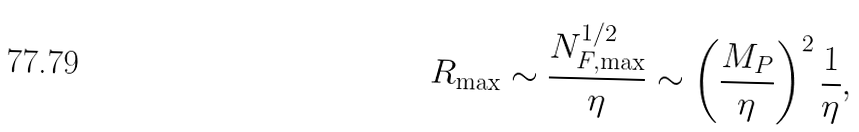<formula> <loc_0><loc_0><loc_500><loc_500>R _ { \max } \sim \frac { N _ { F , \max } ^ { 1 / 2 } } \eta \sim \left ( \frac { M _ { P } } \eta \right ) ^ { 2 } \frac { 1 } { \eta } ,</formula> 